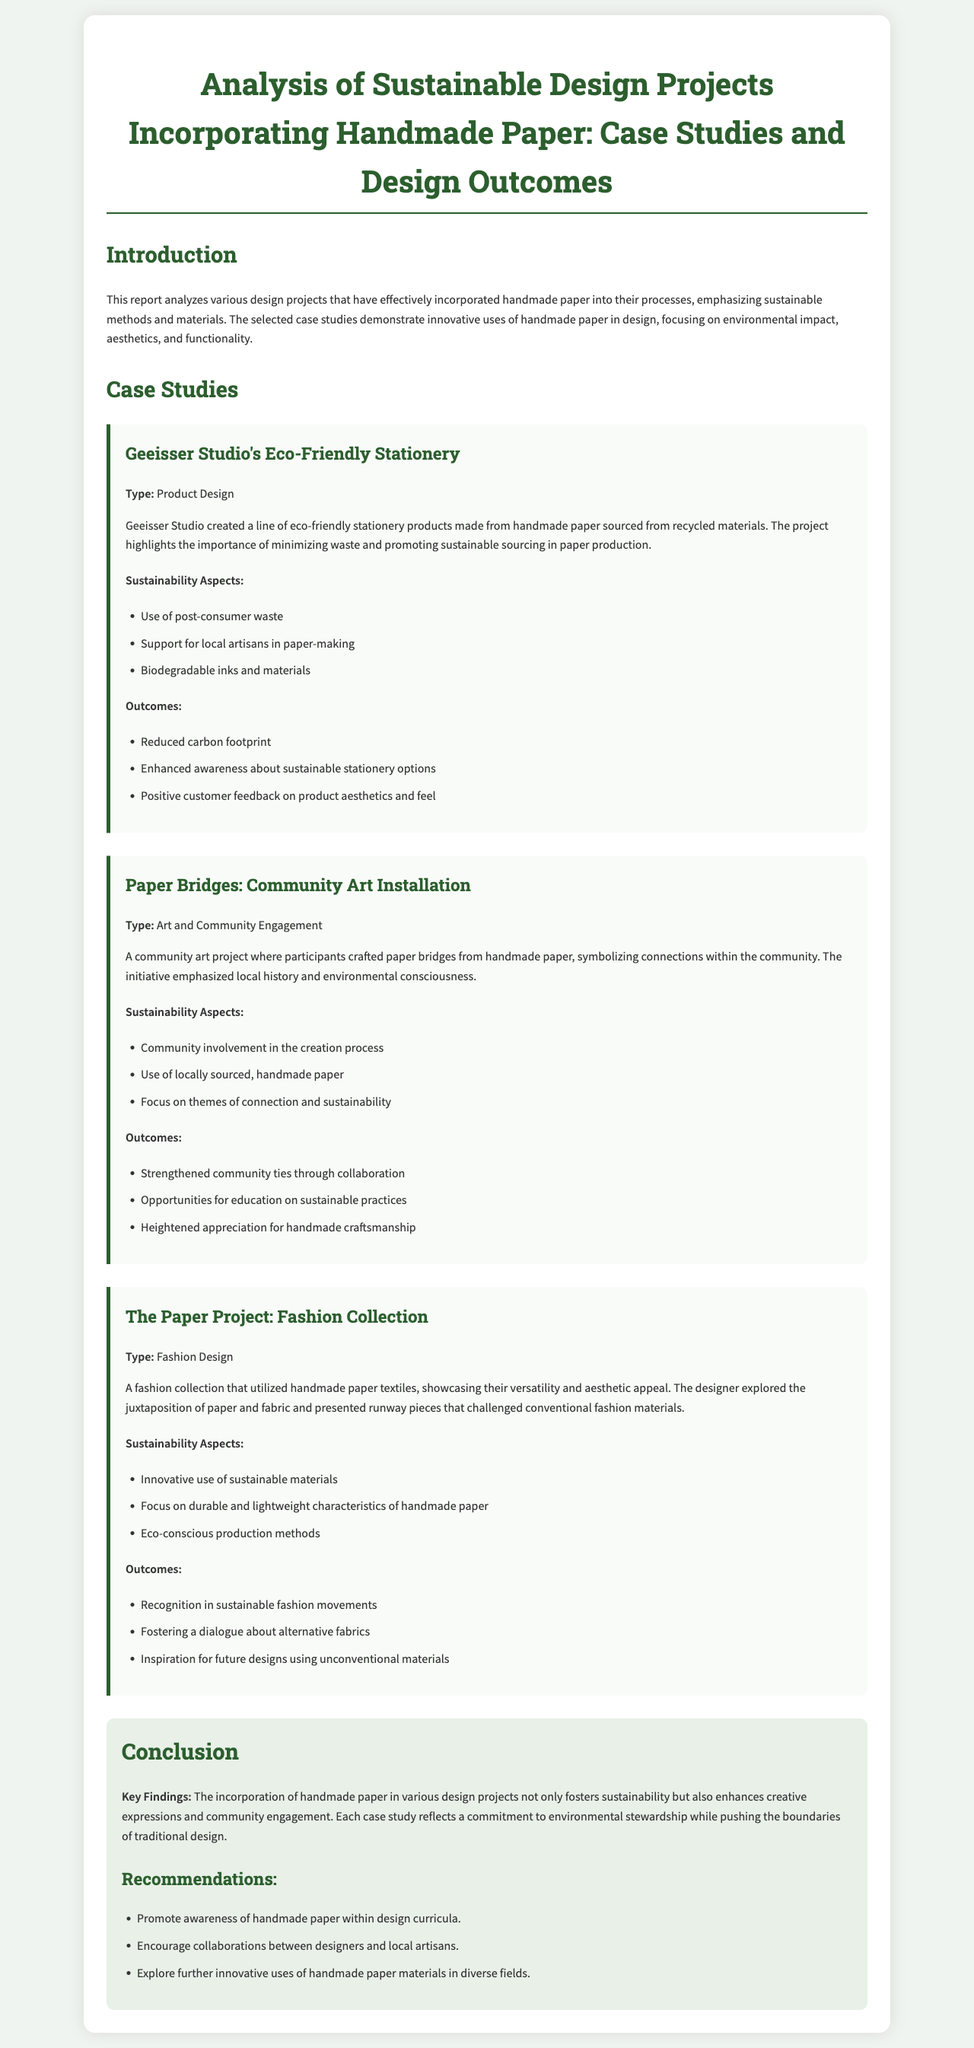What type of project is Geeisser Studio's Eco-Friendly Stationery? The document specifies that Geeisser Studio's project is categorized under Product Design.
Answer: Product Design What are the sustainability aspects of the Paper Bridges project? The document lists several sustainability aspects for the Paper Bridges project, including community involvement and the use of locally sourced paper.
Answer: Community involvement, locally sourced, sustainability themes What was the outcome of The Paper Project in relation to fashion? According to the document, one of the outcomes mentioned is recognition in sustainable fashion movements.
Answer: Recognition in sustainable fashion movements Which materials were highlighted in The Paper Project? The document emphasizes the innovative use of sustainable materials specifically designed for fashion, including handmade paper textiles.
Answer: Handmade paper textiles What key findings are mentioned in the conclusion? The conclusion provides insights that highlight the incorporation of handmade paper fostering sustainability and enhancing creative expressions.
Answer: Fosters sustainability, enhances creative expressions What recommendation is given for design curricula? The document suggests promoting awareness of handmade paper within design curricula as a key recommendation.
Answer: Promote awareness of handmade paper What impact did the community art project have on community ties? The document states that the Paper Bridges project strengthened community ties through collaboration.
Answer: Strengthened community ties What type of design is The Paper Project associated with? The document identifies The Paper Project specifically as a Fashion Design initiative.
Answer: Fashion Design How many case studies are discussed in this report? The document describes three distinct case studies related to sustainable design projects.
Answer: Three 